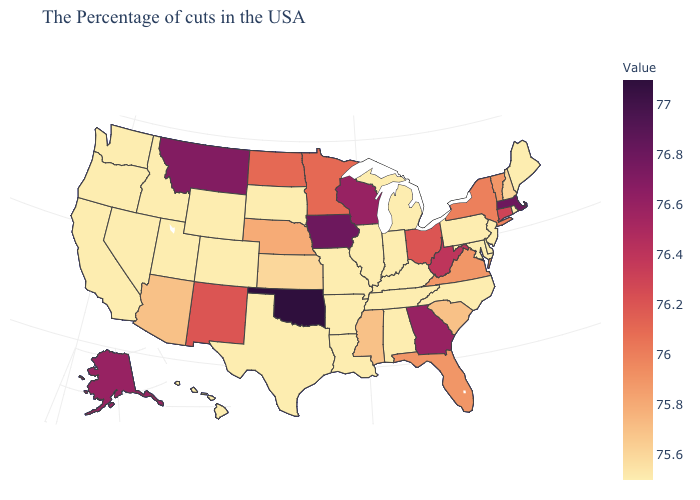Which states have the lowest value in the MidWest?
Be succinct. Michigan, Indiana, Illinois, Missouri, South Dakota. Does Alabama have a higher value than Montana?
Give a very brief answer. No. Does New Hampshire have the lowest value in the USA?
Write a very short answer. No. Does New Mexico have the highest value in the West?
Concise answer only. No. Does Kansas have the lowest value in the USA?
Quick response, please. No. Among the states that border North Carolina , does Tennessee have the highest value?
Be succinct. No. Which states have the highest value in the USA?
Answer briefly. Oklahoma. 